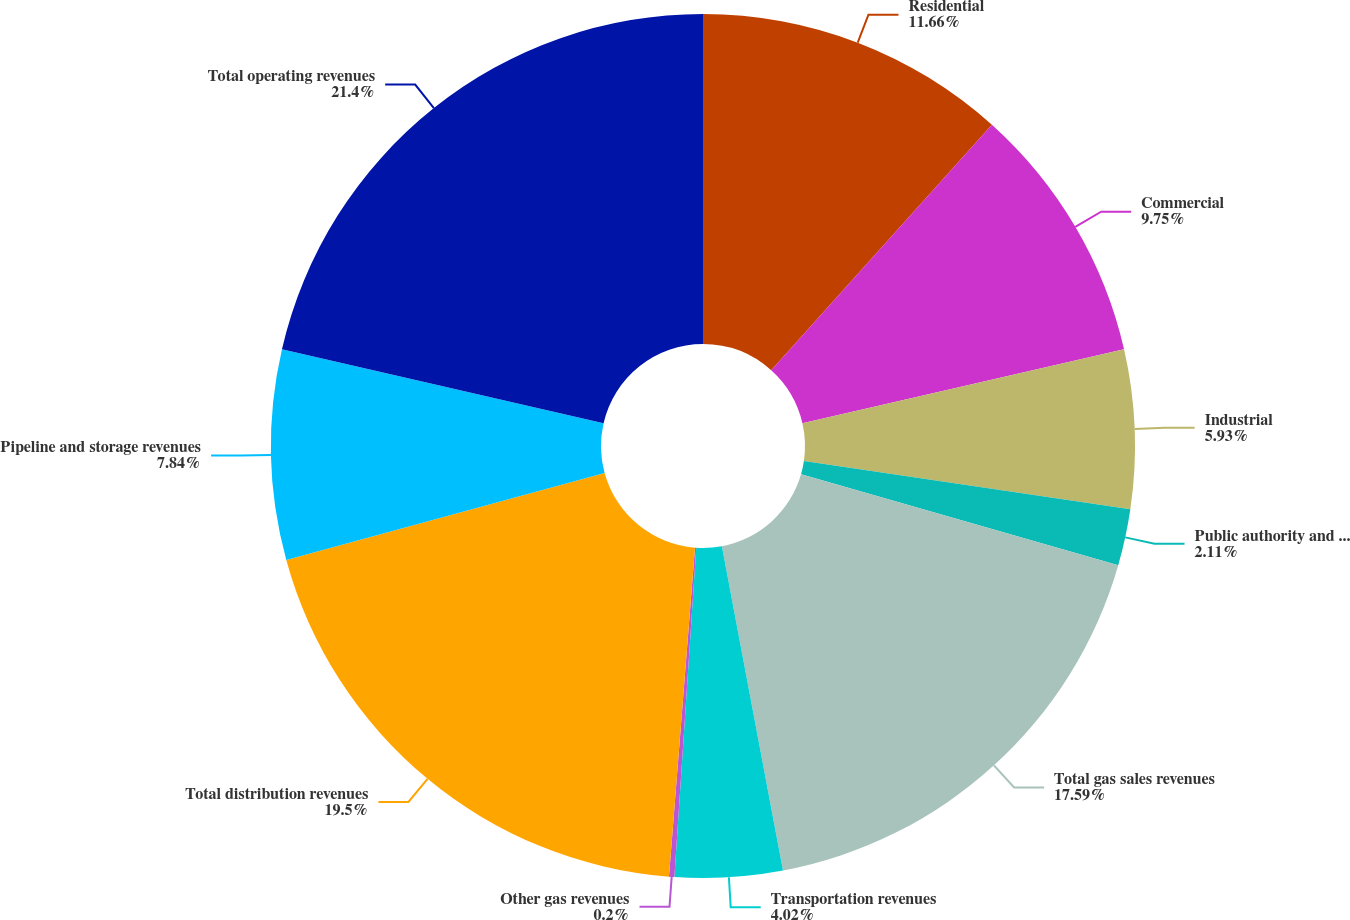Convert chart to OTSL. <chart><loc_0><loc_0><loc_500><loc_500><pie_chart><fcel>Residential<fcel>Commercial<fcel>Industrial<fcel>Public authority and other<fcel>Total gas sales revenues<fcel>Transportation revenues<fcel>Other gas revenues<fcel>Total distribution revenues<fcel>Pipeline and storage revenues<fcel>Total operating revenues<nl><fcel>11.66%<fcel>9.75%<fcel>5.93%<fcel>2.11%<fcel>17.59%<fcel>4.02%<fcel>0.2%<fcel>19.5%<fcel>7.84%<fcel>21.41%<nl></chart> 